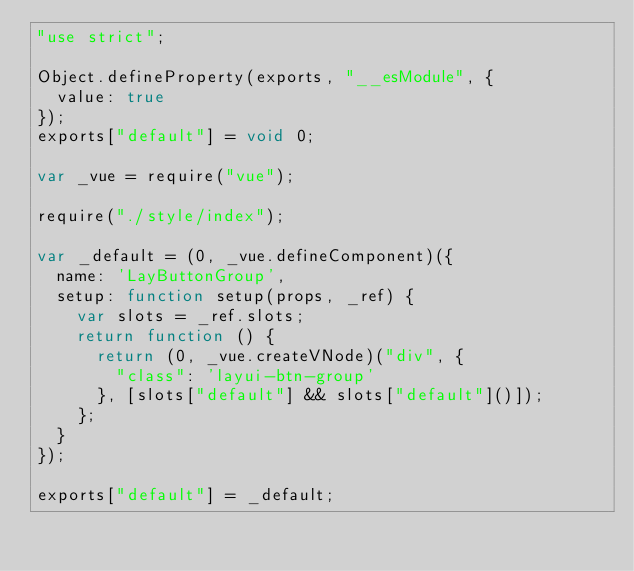<code> <loc_0><loc_0><loc_500><loc_500><_JavaScript_>"use strict";

Object.defineProperty(exports, "__esModule", {
  value: true
});
exports["default"] = void 0;

var _vue = require("vue");

require("./style/index");

var _default = (0, _vue.defineComponent)({
  name: 'LayButtonGroup',
  setup: function setup(props, _ref) {
    var slots = _ref.slots;
    return function () {
      return (0, _vue.createVNode)("div", {
        "class": 'layui-btn-group'
      }, [slots["default"] && slots["default"]()]);
    };
  }
});

exports["default"] = _default;</code> 